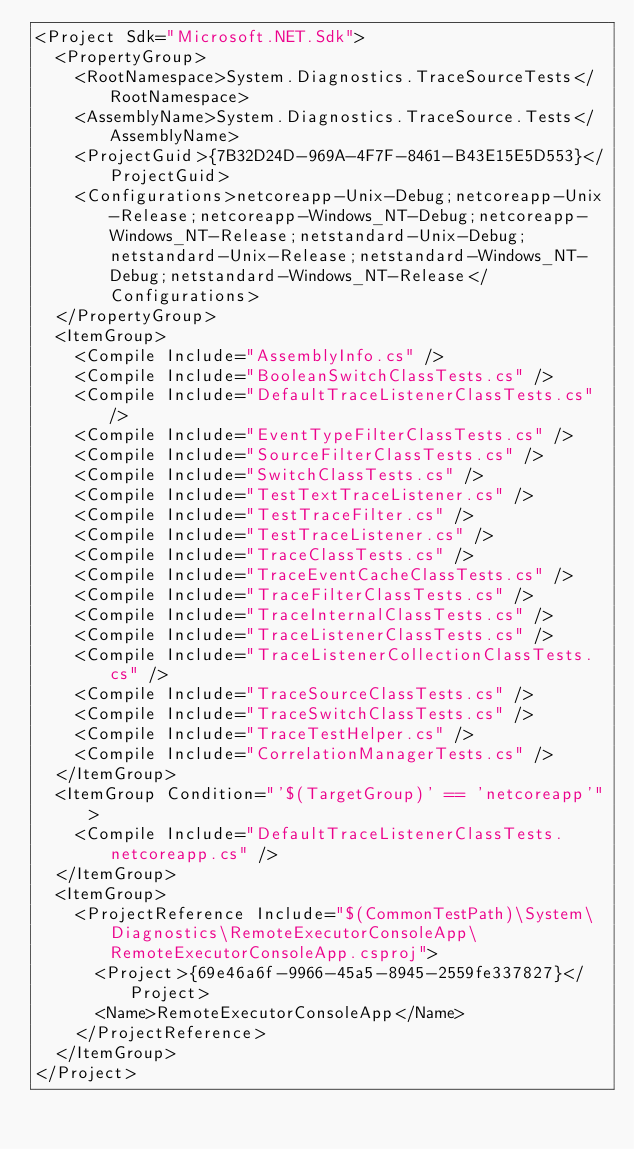<code> <loc_0><loc_0><loc_500><loc_500><_XML_><Project Sdk="Microsoft.NET.Sdk">
  <PropertyGroup>
    <RootNamespace>System.Diagnostics.TraceSourceTests</RootNamespace>
    <AssemblyName>System.Diagnostics.TraceSource.Tests</AssemblyName>
    <ProjectGuid>{7B32D24D-969A-4F7F-8461-B43E15E5D553}</ProjectGuid>
    <Configurations>netcoreapp-Unix-Debug;netcoreapp-Unix-Release;netcoreapp-Windows_NT-Debug;netcoreapp-Windows_NT-Release;netstandard-Unix-Debug;netstandard-Unix-Release;netstandard-Windows_NT-Debug;netstandard-Windows_NT-Release</Configurations>
  </PropertyGroup>
  <ItemGroup>
    <Compile Include="AssemblyInfo.cs" />
    <Compile Include="BooleanSwitchClassTests.cs" />
    <Compile Include="DefaultTraceListenerClassTests.cs" />
    <Compile Include="EventTypeFilterClassTests.cs" />
    <Compile Include="SourceFilterClassTests.cs" />
    <Compile Include="SwitchClassTests.cs" />
    <Compile Include="TestTextTraceListener.cs" />
    <Compile Include="TestTraceFilter.cs" />
    <Compile Include="TestTraceListener.cs" />
    <Compile Include="TraceClassTests.cs" />
    <Compile Include="TraceEventCacheClassTests.cs" />
    <Compile Include="TraceFilterClassTests.cs" />
    <Compile Include="TraceInternalClassTests.cs" />
    <Compile Include="TraceListenerClassTests.cs" />
    <Compile Include="TraceListenerCollectionClassTests.cs" />
    <Compile Include="TraceSourceClassTests.cs" />
    <Compile Include="TraceSwitchClassTests.cs" />
    <Compile Include="TraceTestHelper.cs" />
    <Compile Include="CorrelationManagerTests.cs" />
  </ItemGroup>
  <ItemGroup Condition="'$(TargetGroup)' == 'netcoreapp'">
    <Compile Include="DefaultTraceListenerClassTests.netcoreapp.cs" />
  </ItemGroup>
  <ItemGroup>
    <ProjectReference Include="$(CommonTestPath)\System\Diagnostics\RemoteExecutorConsoleApp\RemoteExecutorConsoleApp.csproj">
      <Project>{69e46a6f-9966-45a5-8945-2559fe337827}</Project>
      <Name>RemoteExecutorConsoleApp</Name>
    </ProjectReference>
  </ItemGroup>
</Project></code> 